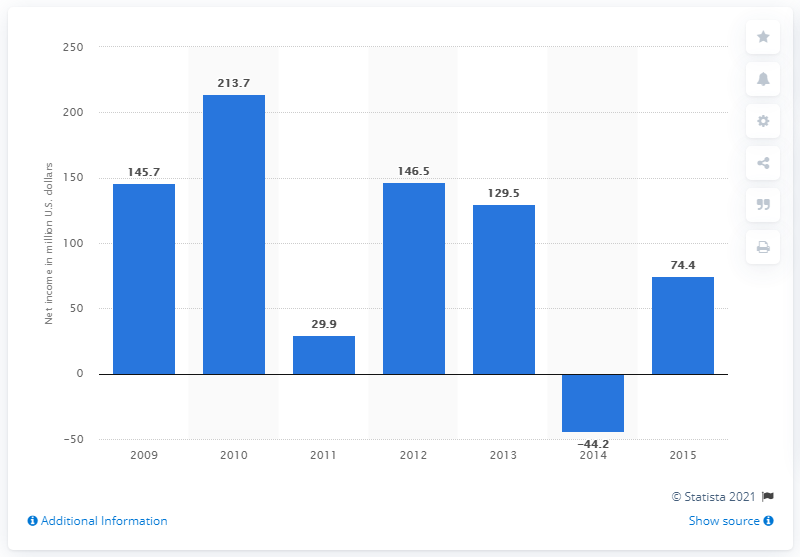Give some essential details in this illustration. In 2009, NBTY generated a net income of 146.5 dollars. 